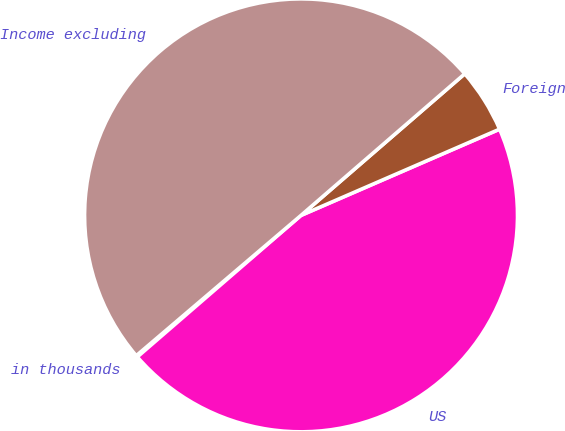<chart> <loc_0><loc_0><loc_500><loc_500><pie_chart><fcel>in thousands<fcel>US<fcel>Foreign<fcel>Income excluding<nl><fcel>0.12%<fcel>45.17%<fcel>4.83%<fcel>49.88%<nl></chart> 